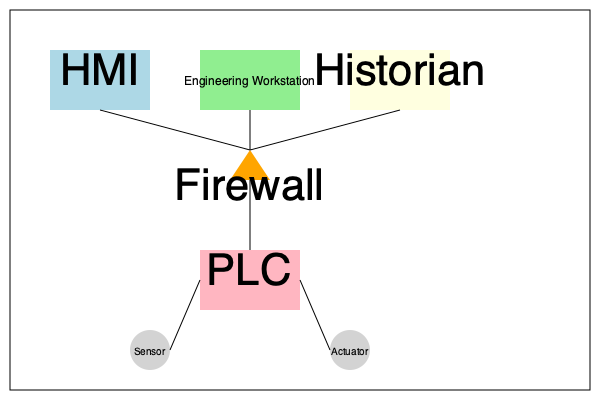In the given industrial control system diagram, which component represents the most critical point for implementing security measures to protect against external cyber threats, and why? To identify the most critical point for implementing security measures against external cyber threats, we need to analyze the components and their roles in the industrial control system:

1. HMI (Human-Machine Interface): Used for operator interaction and system monitoring.
2. Engineering Workstation: Used for programming and configuring the system.
3. Historian: Stores historical data for analysis and reporting.
4. Firewall: Controls and monitors network traffic between the upper-level components and the PLC.
5. PLC (Programmable Logic Controller): Controls the physical processes through sensors and actuators.
6. Sensors and Actuators: Interface with the physical world.

The most critical point for implementing security measures is the firewall, because:

1. It acts as a barrier between the upper-level components (HMI, Engineering Workstation, and Historian) and the lower-level components (PLC, sensors, and actuators).
2. It can control and monitor all network traffic between these two levels, potentially blocking unauthorized access attempts.
3. It's the primary defense against external cyber threats trying to access the control system from the corporate network or the internet.
4. Properly configured, it can prevent malicious commands from reaching the PLC and affecting the physical processes.
5. It can also help prevent data exfiltration from the control system to external networks.

While other components also require security measures, the firewall represents the most critical point for protecting against external cyber threats due to its strategic position in the network architecture.
Answer: Firewall 